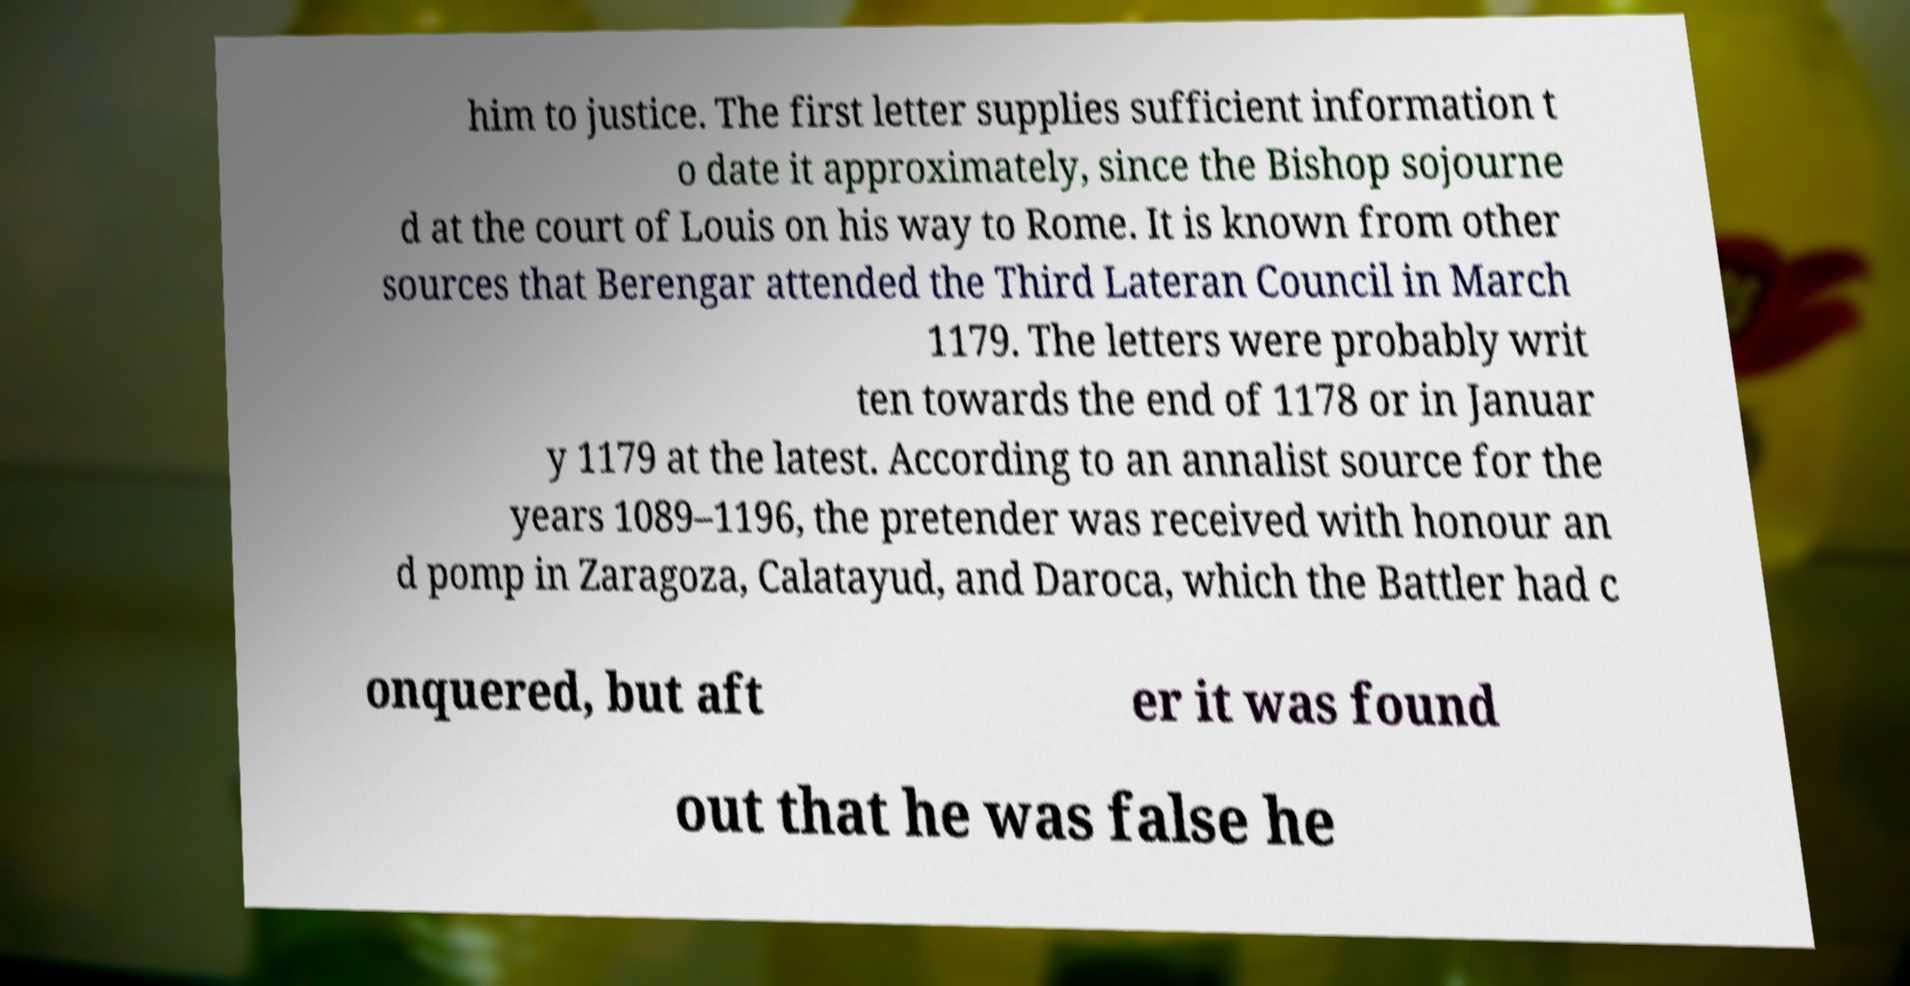Could you extract and type out the text from this image? him to justice. The first letter supplies sufficient information t o date it approximately, since the Bishop sojourne d at the court of Louis on his way to Rome. It is known from other sources that Berengar attended the Third Lateran Council in March 1179. The letters were probably writ ten towards the end of 1178 or in Januar y 1179 at the latest. According to an annalist source for the years 1089–1196, the pretender was received with honour an d pomp in Zaragoza, Calatayud, and Daroca, which the Battler had c onquered, but aft er it was found out that he was false he 